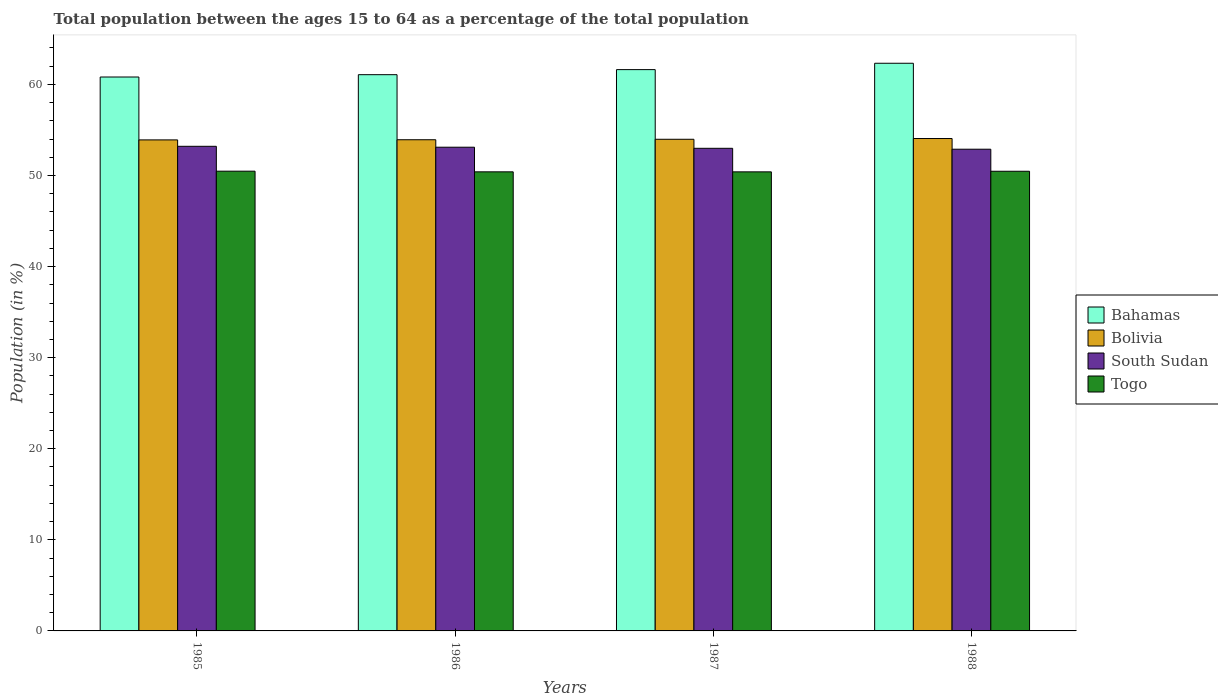Are the number of bars per tick equal to the number of legend labels?
Offer a terse response. Yes. How many bars are there on the 2nd tick from the right?
Provide a succinct answer. 4. What is the percentage of the population ages 15 to 64 in Bolivia in 1986?
Make the answer very short. 53.93. Across all years, what is the maximum percentage of the population ages 15 to 64 in South Sudan?
Your answer should be compact. 53.21. Across all years, what is the minimum percentage of the population ages 15 to 64 in South Sudan?
Ensure brevity in your answer.  52.89. In which year was the percentage of the population ages 15 to 64 in South Sudan minimum?
Your response must be concise. 1988. What is the total percentage of the population ages 15 to 64 in Togo in the graph?
Ensure brevity in your answer.  201.74. What is the difference between the percentage of the population ages 15 to 64 in Bolivia in 1985 and that in 1986?
Keep it short and to the point. -0.02. What is the difference between the percentage of the population ages 15 to 64 in Bolivia in 1986 and the percentage of the population ages 15 to 64 in Bahamas in 1985?
Make the answer very short. -6.89. What is the average percentage of the population ages 15 to 64 in South Sudan per year?
Keep it short and to the point. 53.05. In the year 1987, what is the difference between the percentage of the population ages 15 to 64 in Bolivia and percentage of the population ages 15 to 64 in Bahamas?
Provide a short and direct response. -7.65. What is the ratio of the percentage of the population ages 15 to 64 in Togo in 1987 to that in 1988?
Give a very brief answer. 1. Is the percentage of the population ages 15 to 64 in South Sudan in 1985 less than that in 1987?
Offer a terse response. No. What is the difference between the highest and the second highest percentage of the population ages 15 to 64 in Bolivia?
Ensure brevity in your answer.  0.08. What is the difference between the highest and the lowest percentage of the population ages 15 to 64 in Bolivia?
Provide a short and direct response. 0.15. In how many years, is the percentage of the population ages 15 to 64 in Togo greater than the average percentage of the population ages 15 to 64 in Togo taken over all years?
Ensure brevity in your answer.  2. What does the 2nd bar from the right in 1987 represents?
Ensure brevity in your answer.  South Sudan. How many bars are there?
Keep it short and to the point. 16. Are all the bars in the graph horizontal?
Your response must be concise. No. How many years are there in the graph?
Your answer should be very brief. 4. What is the difference between two consecutive major ticks on the Y-axis?
Offer a very short reply. 10. Are the values on the major ticks of Y-axis written in scientific E-notation?
Your response must be concise. No. Does the graph contain any zero values?
Give a very brief answer. No. Where does the legend appear in the graph?
Your answer should be compact. Center right. How many legend labels are there?
Your answer should be compact. 4. What is the title of the graph?
Provide a succinct answer. Total population between the ages 15 to 64 as a percentage of the total population. What is the label or title of the Y-axis?
Offer a terse response. Population (in %). What is the Population (in %) of Bahamas in 1985?
Ensure brevity in your answer.  60.81. What is the Population (in %) in Bolivia in 1985?
Make the answer very short. 53.91. What is the Population (in %) in South Sudan in 1985?
Provide a succinct answer. 53.21. What is the Population (in %) of Togo in 1985?
Your response must be concise. 50.47. What is the Population (in %) of Bahamas in 1986?
Offer a very short reply. 61.07. What is the Population (in %) of Bolivia in 1986?
Your answer should be compact. 53.93. What is the Population (in %) of South Sudan in 1986?
Make the answer very short. 53.11. What is the Population (in %) in Togo in 1986?
Provide a short and direct response. 50.4. What is the Population (in %) in Bahamas in 1987?
Give a very brief answer. 61.63. What is the Population (in %) of Bolivia in 1987?
Your response must be concise. 53.98. What is the Population (in %) of South Sudan in 1987?
Keep it short and to the point. 52.99. What is the Population (in %) of Togo in 1987?
Offer a very short reply. 50.4. What is the Population (in %) in Bahamas in 1988?
Give a very brief answer. 62.32. What is the Population (in %) of Bolivia in 1988?
Your response must be concise. 54.06. What is the Population (in %) in South Sudan in 1988?
Your answer should be compact. 52.89. What is the Population (in %) of Togo in 1988?
Ensure brevity in your answer.  50.47. Across all years, what is the maximum Population (in %) of Bahamas?
Provide a succinct answer. 62.32. Across all years, what is the maximum Population (in %) of Bolivia?
Your answer should be compact. 54.06. Across all years, what is the maximum Population (in %) in South Sudan?
Keep it short and to the point. 53.21. Across all years, what is the maximum Population (in %) in Togo?
Give a very brief answer. 50.47. Across all years, what is the minimum Population (in %) in Bahamas?
Your response must be concise. 60.81. Across all years, what is the minimum Population (in %) in Bolivia?
Provide a short and direct response. 53.91. Across all years, what is the minimum Population (in %) of South Sudan?
Ensure brevity in your answer.  52.89. Across all years, what is the minimum Population (in %) in Togo?
Provide a short and direct response. 50.4. What is the total Population (in %) of Bahamas in the graph?
Your answer should be compact. 245.83. What is the total Population (in %) of Bolivia in the graph?
Offer a very short reply. 215.87. What is the total Population (in %) of South Sudan in the graph?
Provide a short and direct response. 212.19. What is the total Population (in %) of Togo in the graph?
Offer a terse response. 201.74. What is the difference between the Population (in %) of Bahamas in 1985 and that in 1986?
Offer a very short reply. -0.26. What is the difference between the Population (in %) in Bolivia in 1985 and that in 1986?
Provide a short and direct response. -0.02. What is the difference between the Population (in %) in Togo in 1985 and that in 1986?
Ensure brevity in your answer.  0.07. What is the difference between the Population (in %) in Bahamas in 1985 and that in 1987?
Give a very brief answer. -0.81. What is the difference between the Population (in %) in Bolivia in 1985 and that in 1987?
Offer a very short reply. -0.07. What is the difference between the Population (in %) of South Sudan in 1985 and that in 1987?
Ensure brevity in your answer.  0.22. What is the difference between the Population (in %) of Togo in 1985 and that in 1987?
Provide a short and direct response. 0.07. What is the difference between the Population (in %) in Bahamas in 1985 and that in 1988?
Your answer should be compact. -1.51. What is the difference between the Population (in %) of Bolivia in 1985 and that in 1988?
Make the answer very short. -0.15. What is the difference between the Population (in %) in South Sudan in 1985 and that in 1988?
Provide a short and direct response. 0.32. What is the difference between the Population (in %) of Togo in 1985 and that in 1988?
Your answer should be very brief. 0.01. What is the difference between the Population (in %) in Bahamas in 1986 and that in 1987?
Ensure brevity in your answer.  -0.56. What is the difference between the Population (in %) in Bolivia in 1986 and that in 1987?
Keep it short and to the point. -0.05. What is the difference between the Population (in %) in South Sudan in 1986 and that in 1987?
Provide a succinct answer. 0.12. What is the difference between the Population (in %) in Togo in 1986 and that in 1987?
Keep it short and to the point. 0. What is the difference between the Population (in %) of Bahamas in 1986 and that in 1988?
Provide a short and direct response. -1.25. What is the difference between the Population (in %) of Bolivia in 1986 and that in 1988?
Provide a succinct answer. -0.13. What is the difference between the Population (in %) in South Sudan in 1986 and that in 1988?
Your answer should be very brief. 0.22. What is the difference between the Population (in %) of Togo in 1986 and that in 1988?
Offer a very short reply. -0.06. What is the difference between the Population (in %) in Bahamas in 1987 and that in 1988?
Provide a short and direct response. -0.7. What is the difference between the Population (in %) in Bolivia in 1987 and that in 1988?
Offer a terse response. -0.08. What is the difference between the Population (in %) in South Sudan in 1987 and that in 1988?
Give a very brief answer. 0.1. What is the difference between the Population (in %) in Togo in 1987 and that in 1988?
Your response must be concise. -0.07. What is the difference between the Population (in %) in Bahamas in 1985 and the Population (in %) in Bolivia in 1986?
Ensure brevity in your answer.  6.89. What is the difference between the Population (in %) in Bahamas in 1985 and the Population (in %) in South Sudan in 1986?
Provide a short and direct response. 7.71. What is the difference between the Population (in %) in Bahamas in 1985 and the Population (in %) in Togo in 1986?
Provide a succinct answer. 10.41. What is the difference between the Population (in %) in Bolivia in 1985 and the Population (in %) in South Sudan in 1986?
Offer a very short reply. 0.8. What is the difference between the Population (in %) in Bolivia in 1985 and the Population (in %) in Togo in 1986?
Your response must be concise. 3.51. What is the difference between the Population (in %) in South Sudan in 1985 and the Population (in %) in Togo in 1986?
Provide a short and direct response. 2.8. What is the difference between the Population (in %) in Bahamas in 1985 and the Population (in %) in Bolivia in 1987?
Your answer should be compact. 6.84. What is the difference between the Population (in %) of Bahamas in 1985 and the Population (in %) of South Sudan in 1987?
Provide a short and direct response. 7.83. What is the difference between the Population (in %) of Bahamas in 1985 and the Population (in %) of Togo in 1987?
Ensure brevity in your answer.  10.41. What is the difference between the Population (in %) of Bolivia in 1985 and the Population (in %) of South Sudan in 1987?
Keep it short and to the point. 0.92. What is the difference between the Population (in %) of Bolivia in 1985 and the Population (in %) of Togo in 1987?
Make the answer very short. 3.51. What is the difference between the Population (in %) of South Sudan in 1985 and the Population (in %) of Togo in 1987?
Offer a terse response. 2.81. What is the difference between the Population (in %) of Bahamas in 1985 and the Population (in %) of Bolivia in 1988?
Your answer should be compact. 6.75. What is the difference between the Population (in %) in Bahamas in 1985 and the Population (in %) in South Sudan in 1988?
Your response must be concise. 7.93. What is the difference between the Population (in %) of Bahamas in 1985 and the Population (in %) of Togo in 1988?
Your response must be concise. 10.35. What is the difference between the Population (in %) in Bolivia in 1985 and the Population (in %) in South Sudan in 1988?
Your answer should be very brief. 1.02. What is the difference between the Population (in %) in Bolivia in 1985 and the Population (in %) in Togo in 1988?
Make the answer very short. 3.44. What is the difference between the Population (in %) in South Sudan in 1985 and the Population (in %) in Togo in 1988?
Provide a succinct answer. 2.74. What is the difference between the Population (in %) in Bahamas in 1986 and the Population (in %) in Bolivia in 1987?
Keep it short and to the point. 7.09. What is the difference between the Population (in %) of Bahamas in 1986 and the Population (in %) of South Sudan in 1987?
Your answer should be very brief. 8.08. What is the difference between the Population (in %) in Bahamas in 1986 and the Population (in %) in Togo in 1987?
Give a very brief answer. 10.67. What is the difference between the Population (in %) of Bolivia in 1986 and the Population (in %) of South Sudan in 1987?
Offer a very short reply. 0.94. What is the difference between the Population (in %) of Bolivia in 1986 and the Population (in %) of Togo in 1987?
Offer a terse response. 3.53. What is the difference between the Population (in %) in South Sudan in 1986 and the Population (in %) in Togo in 1987?
Provide a short and direct response. 2.71. What is the difference between the Population (in %) of Bahamas in 1986 and the Population (in %) of Bolivia in 1988?
Provide a short and direct response. 7.01. What is the difference between the Population (in %) of Bahamas in 1986 and the Population (in %) of South Sudan in 1988?
Ensure brevity in your answer.  8.18. What is the difference between the Population (in %) of Bahamas in 1986 and the Population (in %) of Togo in 1988?
Offer a very short reply. 10.6. What is the difference between the Population (in %) of Bolivia in 1986 and the Population (in %) of South Sudan in 1988?
Keep it short and to the point. 1.04. What is the difference between the Population (in %) in Bolivia in 1986 and the Population (in %) in Togo in 1988?
Your response must be concise. 3.46. What is the difference between the Population (in %) in South Sudan in 1986 and the Population (in %) in Togo in 1988?
Offer a very short reply. 2.64. What is the difference between the Population (in %) in Bahamas in 1987 and the Population (in %) in Bolivia in 1988?
Ensure brevity in your answer.  7.57. What is the difference between the Population (in %) of Bahamas in 1987 and the Population (in %) of South Sudan in 1988?
Provide a succinct answer. 8.74. What is the difference between the Population (in %) in Bahamas in 1987 and the Population (in %) in Togo in 1988?
Make the answer very short. 11.16. What is the difference between the Population (in %) in Bolivia in 1987 and the Population (in %) in South Sudan in 1988?
Provide a succinct answer. 1.09. What is the difference between the Population (in %) of Bolivia in 1987 and the Population (in %) of Togo in 1988?
Your answer should be compact. 3.51. What is the difference between the Population (in %) in South Sudan in 1987 and the Population (in %) in Togo in 1988?
Provide a short and direct response. 2.52. What is the average Population (in %) in Bahamas per year?
Make the answer very short. 61.46. What is the average Population (in %) in Bolivia per year?
Offer a very short reply. 53.97. What is the average Population (in %) of South Sudan per year?
Give a very brief answer. 53.05. What is the average Population (in %) in Togo per year?
Offer a very short reply. 50.44. In the year 1985, what is the difference between the Population (in %) of Bahamas and Population (in %) of Bolivia?
Provide a succinct answer. 6.9. In the year 1985, what is the difference between the Population (in %) in Bahamas and Population (in %) in South Sudan?
Provide a short and direct response. 7.61. In the year 1985, what is the difference between the Population (in %) in Bahamas and Population (in %) in Togo?
Keep it short and to the point. 10.34. In the year 1985, what is the difference between the Population (in %) of Bolivia and Population (in %) of South Sudan?
Provide a succinct answer. 0.7. In the year 1985, what is the difference between the Population (in %) of Bolivia and Population (in %) of Togo?
Offer a terse response. 3.44. In the year 1985, what is the difference between the Population (in %) of South Sudan and Population (in %) of Togo?
Offer a terse response. 2.73. In the year 1986, what is the difference between the Population (in %) in Bahamas and Population (in %) in Bolivia?
Keep it short and to the point. 7.14. In the year 1986, what is the difference between the Population (in %) in Bahamas and Population (in %) in South Sudan?
Your answer should be very brief. 7.96. In the year 1986, what is the difference between the Population (in %) of Bahamas and Population (in %) of Togo?
Ensure brevity in your answer.  10.67. In the year 1986, what is the difference between the Population (in %) of Bolivia and Population (in %) of South Sudan?
Ensure brevity in your answer.  0.82. In the year 1986, what is the difference between the Population (in %) in Bolivia and Population (in %) in Togo?
Provide a short and direct response. 3.52. In the year 1986, what is the difference between the Population (in %) of South Sudan and Population (in %) of Togo?
Give a very brief answer. 2.7. In the year 1987, what is the difference between the Population (in %) in Bahamas and Population (in %) in Bolivia?
Your answer should be very brief. 7.65. In the year 1987, what is the difference between the Population (in %) of Bahamas and Population (in %) of South Sudan?
Offer a terse response. 8.64. In the year 1987, what is the difference between the Population (in %) of Bahamas and Population (in %) of Togo?
Offer a terse response. 11.23. In the year 1987, what is the difference between the Population (in %) of Bolivia and Population (in %) of South Sudan?
Your answer should be compact. 0.99. In the year 1987, what is the difference between the Population (in %) of Bolivia and Population (in %) of Togo?
Offer a terse response. 3.58. In the year 1987, what is the difference between the Population (in %) of South Sudan and Population (in %) of Togo?
Your answer should be very brief. 2.59. In the year 1988, what is the difference between the Population (in %) in Bahamas and Population (in %) in Bolivia?
Provide a short and direct response. 8.26. In the year 1988, what is the difference between the Population (in %) in Bahamas and Population (in %) in South Sudan?
Give a very brief answer. 9.44. In the year 1988, what is the difference between the Population (in %) in Bahamas and Population (in %) in Togo?
Provide a succinct answer. 11.86. In the year 1988, what is the difference between the Population (in %) in Bolivia and Population (in %) in South Sudan?
Make the answer very short. 1.17. In the year 1988, what is the difference between the Population (in %) of Bolivia and Population (in %) of Togo?
Your response must be concise. 3.59. In the year 1988, what is the difference between the Population (in %) of South Sudan and Population (in %) of Togo?
Your answer should be compact. 2.42. What is the ratio of the Population (in %) of Bahamas in 1985 to that in 1986?
Your answer should be compact. 1. What is the ratio of the Population (in %) in Bolivia in 1985 to that in 1986?
Ensure brevity in your answer.  1. What is the ratio of the Population (in %) of South Sudan in 1985 to that in 1986?
Your response must be concise. 1. What is the ratio of the Population (in %) of Togo in 1985 to that in 1986?
Your answer should be very brief. 1. What is the ratio of the Population (in %) in Bahamas in 1985 to that in 1987?
Make the answer very short. 0.99. What is the ratio of the Population (in %) of South Sudan in 1985 to that in 1987?
Provide a succinct answer. 1. What is the ratio of the Population (in %) of Bahamas in 1985 to that in 1988?
Keep it short and to the point. 0.98. What is the ratio of the Population (in %) of Bolivia in 1985 to that in 1988?
Offer a very short reply. 1. What is the ratio of the Population (in %) in Bahamas in 1986 to that in 1987?
Keep it short and to the point. 0.99. What is the ratio of the Population (in %) of Togo in 1986 to that in 1987?
Offer a terse response. 1. What is the ratio of the Population (in %) of Bahamas in 1986 to that in 1988?
Your answer should be compact. 0.98. What is the ratio of the Population (in %) of Bolivia in 1986 to that in 1988?
Make the answer very short. 1. What is the ratio of the Population (in %) of Bahamas in 1987 to that in 1988?
Provide a succinct answer. 0.99. What is the ratio of the Population (in %) in Bolivia in 1987 to that in 1988?
Give a very brief answer. 1. What is the ratio of the Population (in %) of Togo in 1987 to that in 1988?
Offer a terse response. 1. What is the difference between the highest and the second highest Population (in %) in Bahamas?
Your response must be concise. 0.7. What is the difference between the highest and the second highest Population (in %) of Bolivia?
Your response must be concise. 0.08. What is the difference between the highest and the second highest Population (in %) of South Sudan?
Your answer should be compact. 0.1. What is the difference between the highest and the second highest Population (in %) of Togo?
Your response must be concise. 0.01. What is the difference between the highest and the lowest Population (in %) in Bahamas?
Give a very brief answer. 1.51. What is the difference between the highest and the lowest Population (in %) of Bolivia?
Your response must be concise. 0.15. What is the difference between the highest and the lowest Population (in %) of South Sudan?
Ensure brevity in your answer.  0.32. What is the difference between the highest and the lowest Population (in %) in Togo?
Offer a very short reply. 0.07. 